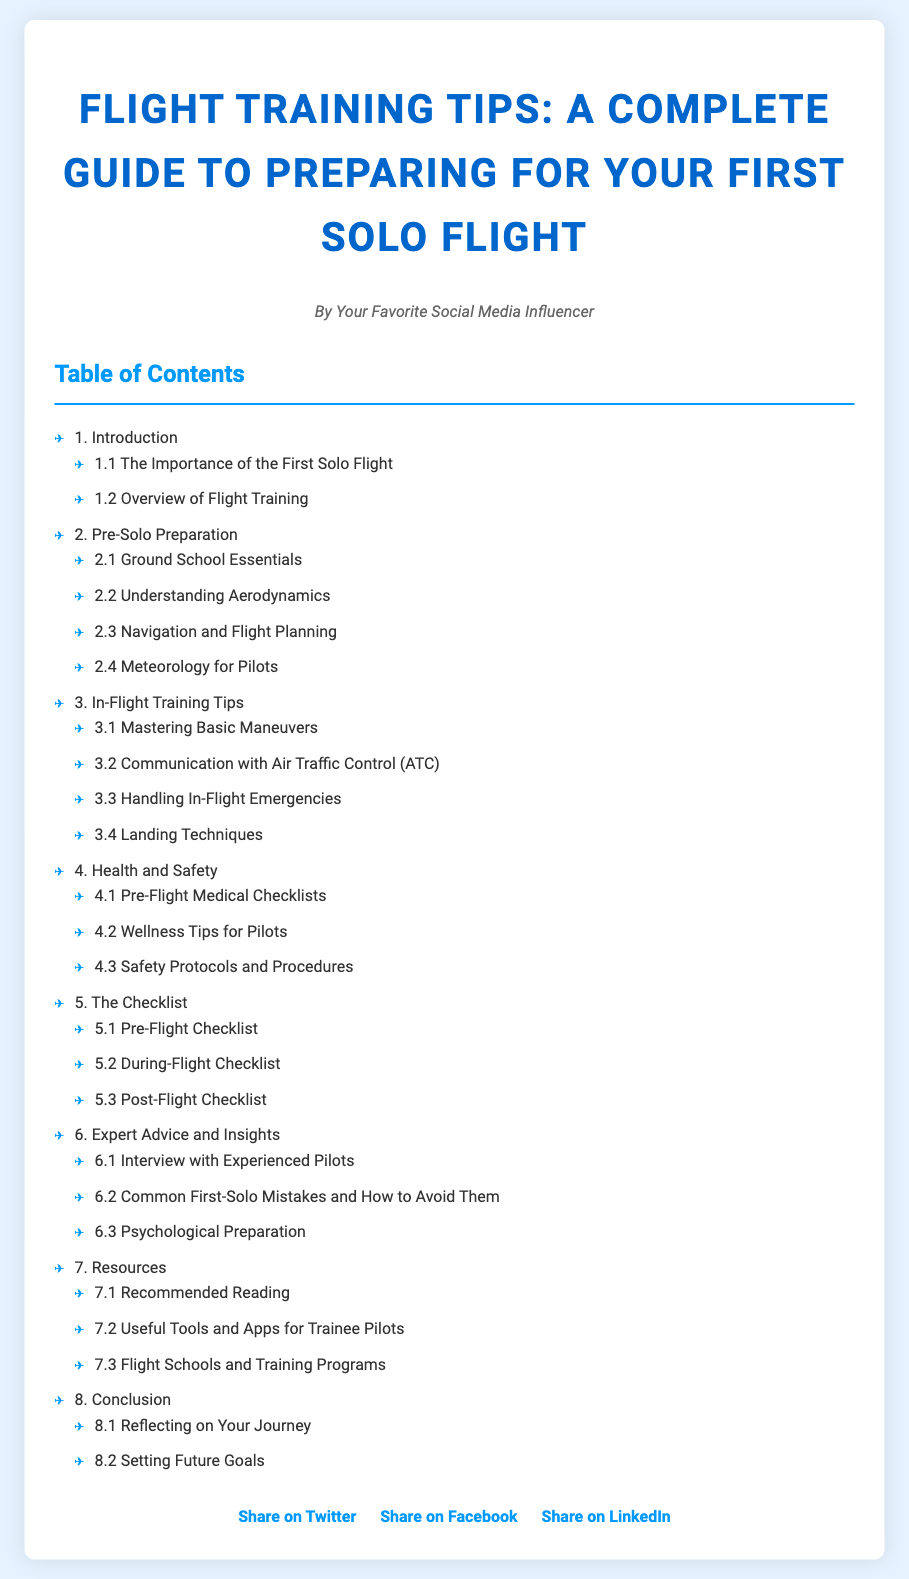What is the title of the document? The title of the document is stated prominently at the top.
Answer: Flight Training Tips: A Complete Guide to Preparing for Your First Solo Flight What section discusses health and safety? The section on health and safety includes specific subtopics relevant to pilots' wellness and protocols.
Answer: 4. Health and Safety How many sub-sections are under the "Pre-Solo Preparation" section? The number of sub-sections can be counted directly from the table of contents.
Answer: 4 Who is the author of the document? The author is mentioned in the author info section.
Answer: Your Favorite Social Media Influencer What is one key topic under "In-Flight Training Tips"? This is a specific subtopic mentioned in the document that pertains to in-flight skills.
Answer: Communication with Air Traffic Control (ATC) What checklist is mentioned first in the "The Checklist" section? The first checklist is explicitly listed under the section dedicated to checklists.
Answer: Pre-Flight Checklist Which section includes "Interview with Experienced Pilots"? This is a specific topic found under the expert advice section in the table of contents.
Answer: 6. Expert Advice and Insights How many main sections are listed in the table of contents? The total number of main sections can be counted from the list provided.
Answer: 8 